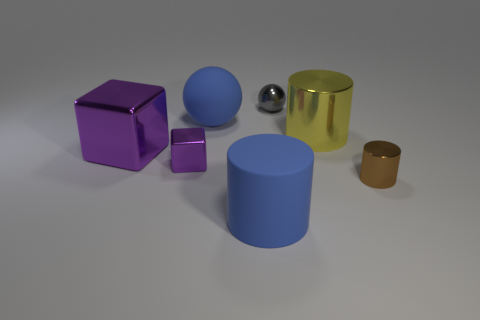Add 2 small cubes. How many objects exist? 9 Subtract all spheres. How many objects are left? 5 Add 2 large cylinders. How many large cylinders are left? 4 Add 6 small red rubber cubes. How many small red rubber cubes exist? 6 Subtract 0 gray cubes. How many objects are left? 7 Subtract all blocks. Subtract all big matte spheres. How many objects are left? 4 